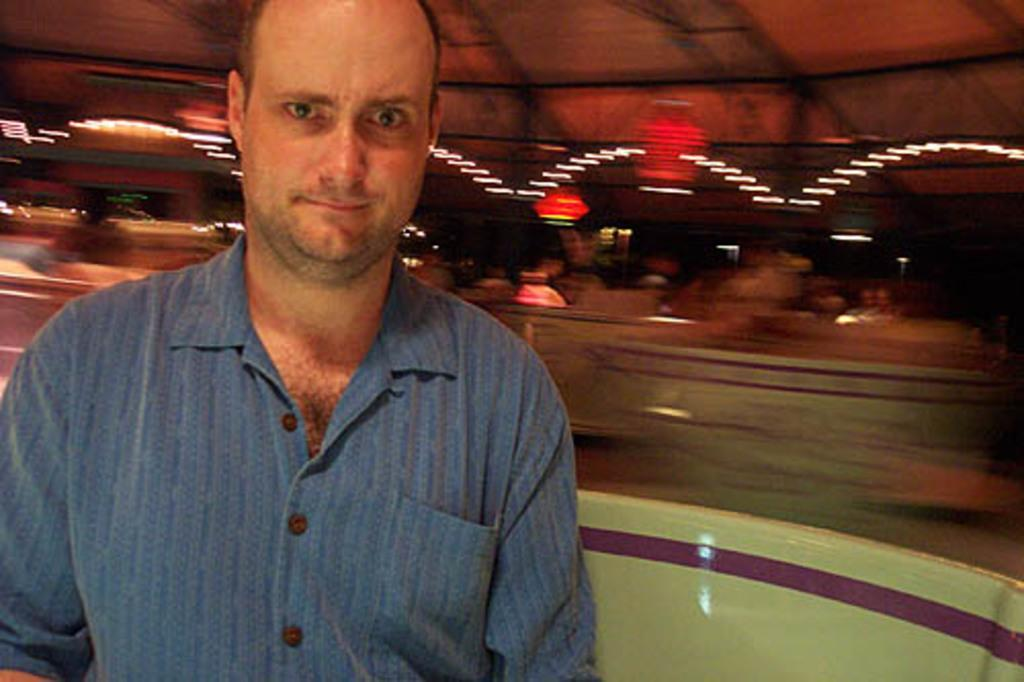Who or what is located in the front of the image? There is a person in the front of the image. What is the white object in the front of the image? The white object in the front of the image is not specified, but it is mentioned as being present. How would you describe the background of the image? The background of the image is blurry. What can be seen in the image that might provide illumination? Lights are visible in the image. What else is present in the background of the image? Objects are present in the background of the image. What type of grain is being harvested in the image? There is no mention of grain in the image. 